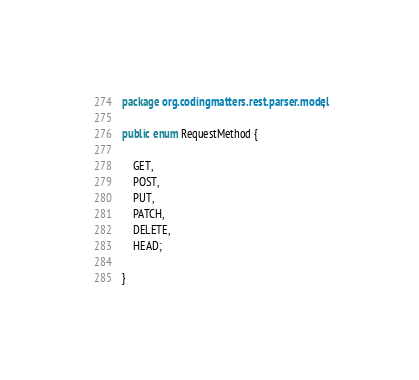Convert code to text. <code><loc_0><loc_0><loc_500><loc_500><_Java_>package org.codingmatters.rest.parser.model;

public enum RequestMethod {

    GET,
    POST,
    PUT,
    PATCH,
    DELETE,
    HEAD;

}
</code> 